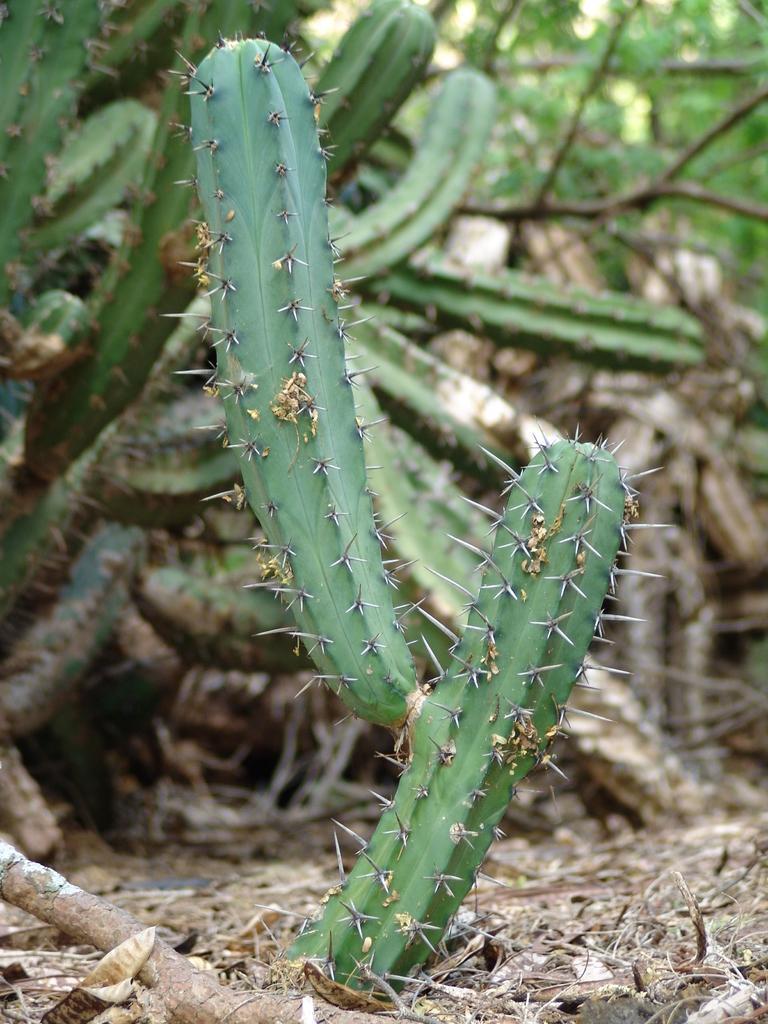Please provide a concise description of this image. In this image we can some cactus plants, and trees, there are some leaves, sticks on the ground. 